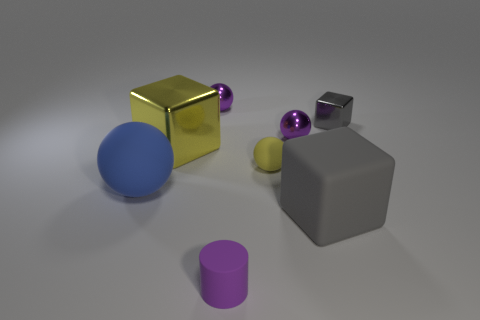Add 1 big objects. How many objects exist? 9 Subtract all cubes. How many objects are left? 5 Add 4 matte cubes. How many matte cubes exist? 5 Subtract 0 gray spheres. How many objects are left? 8 Subtract all big metal things. Subtract all small cylinders. How many objects are left? 6 Add 3 yellow matte things. How many yellow matte things are left? 4 